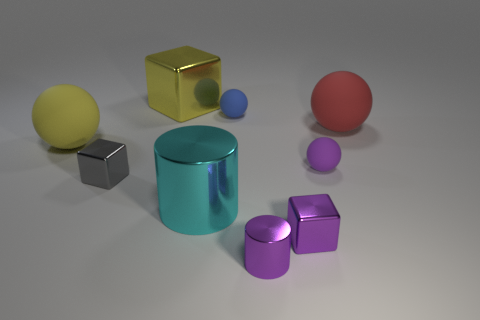Can you tell me which objects in the image are shiny? Certainly, the objects with shiny surfaces in the image include the large gold cube, the small blue sphere, and the medium-sized cyan cylinder. Their surfaces are reflective, allowing light to create notable highlights and giving them a glossy appearance. How does the shininess of these objects affect the way they look compared to the matte objects? The shininess of these objects makes them stand out by reflecting light, creating bright spots and a sense of depth. This contrast with the matte objects, which scatter light more uniformly and lack the reflective highlights, gives a varied visual texture to the scene and conveys information about the materials. 